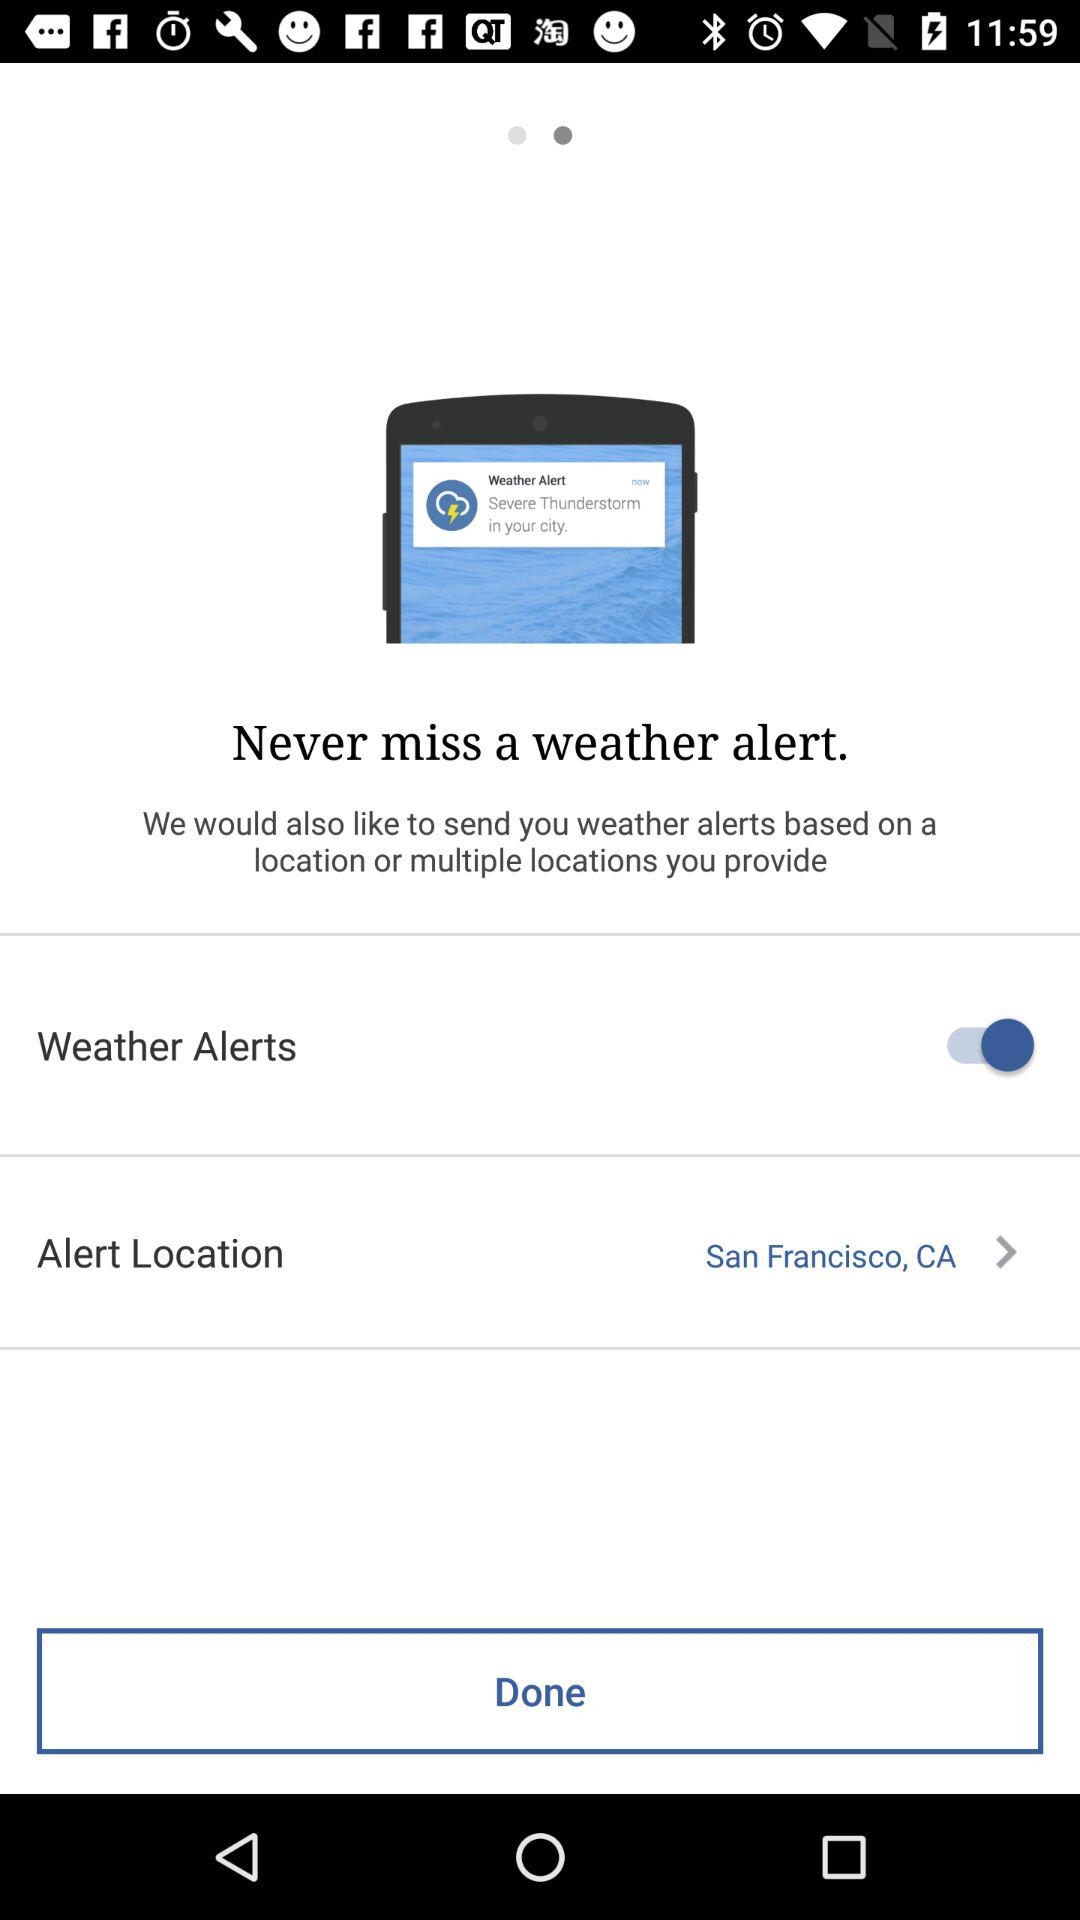What is the status of "Weather Alerts"? The status is "on". 